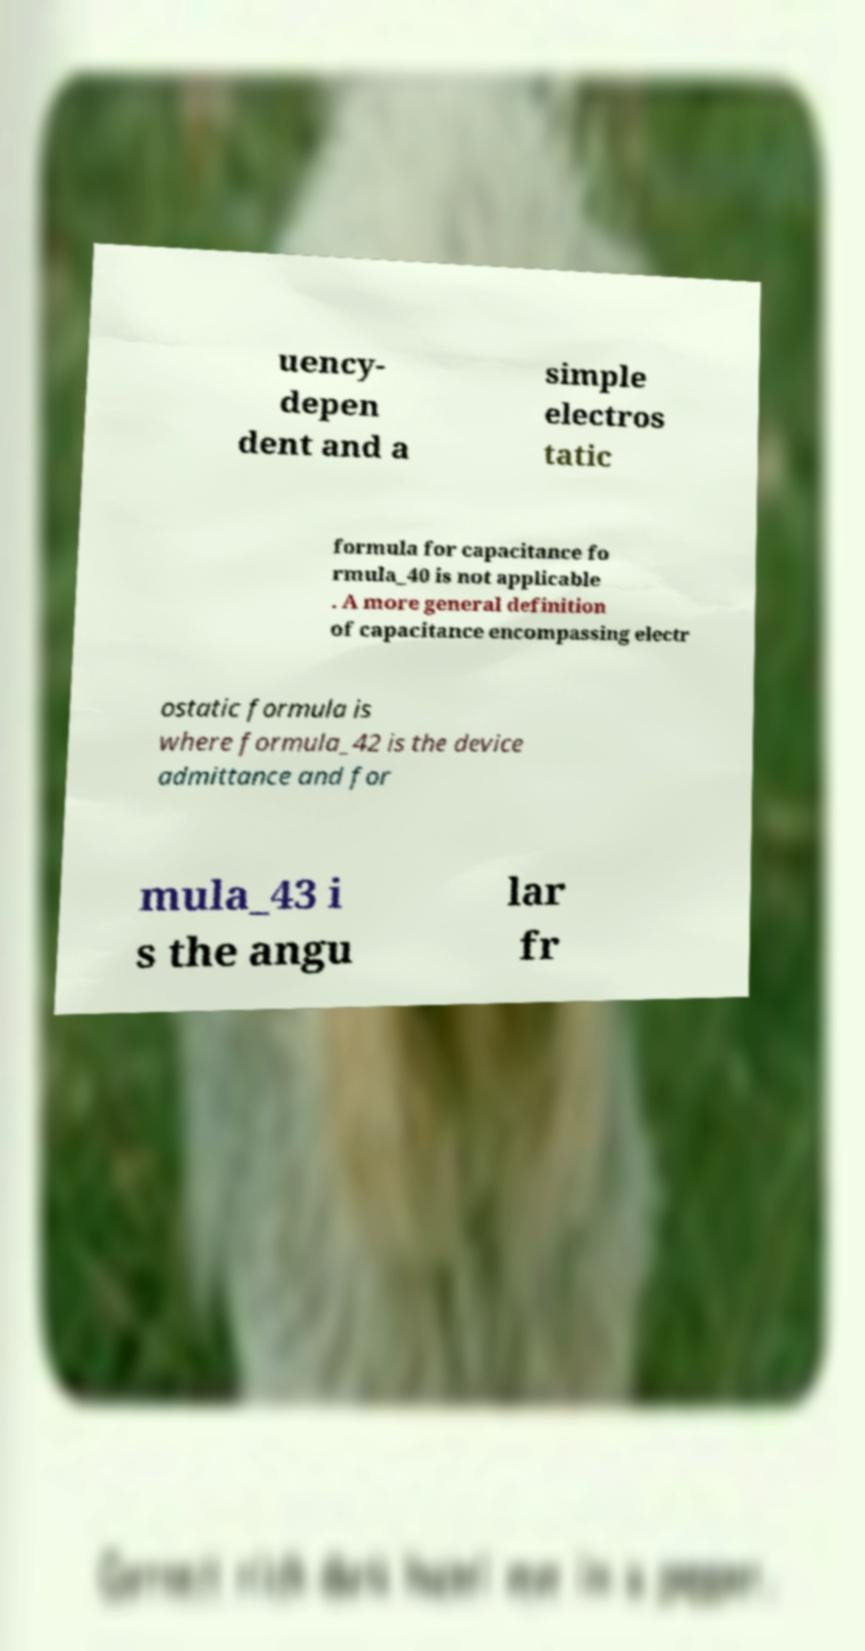For documentation purposes, I need the text within this image transcribed. Could you provide that? uency- depen dent and a simple electros tatic formula for capacitance fo rmula_40 is not applicable . A more general definition of capacitance encompassing electr ostatic formula is where formula_42 is the device admittance and for mula_43 i s the angu lar fr 